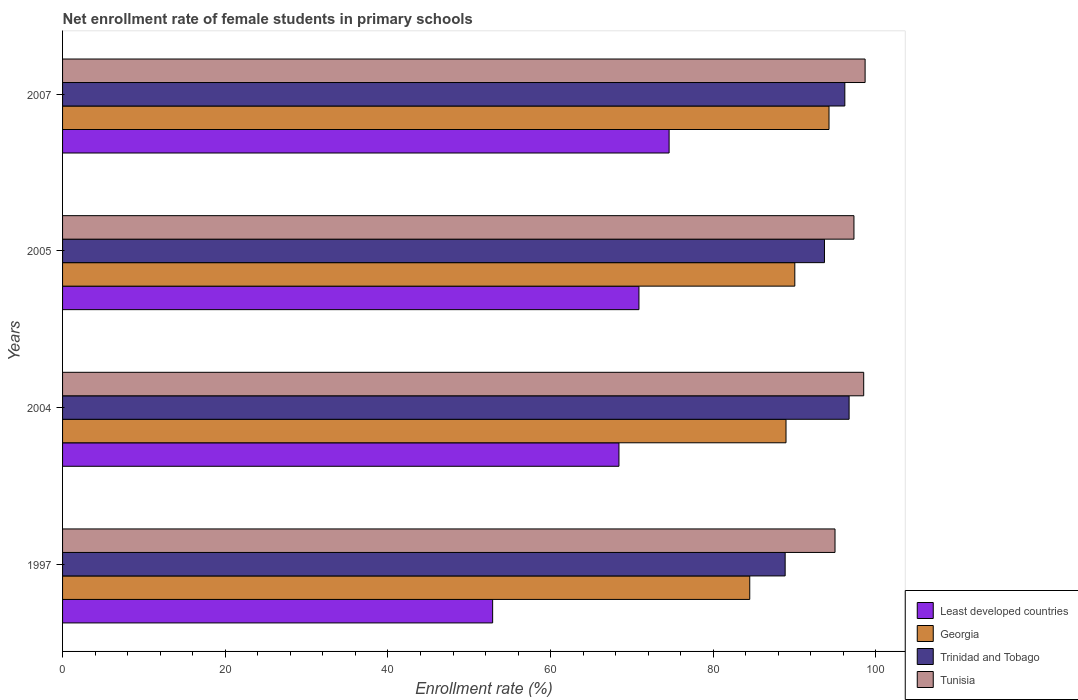How many different coloured bars are there?
Provide a succinct answer. 4. Are the number of bars per tick equal to the number of legend labels?
Your answer should be very brief. Yes. How many bars are there on the 1st tick from the top?
Your answer should be very brief. 4. What is the label of the 1st group of bars from the top?
Your response must be concise. 2007. In how many cases, is the number of bars for a given year not equal to the number of legend labels?
Your response must be concise. 0. What is the net enrollment rate of female students in primary schools in Tunisia in 1997?
Your response must be concise. 94.97. Across all years, what is the maximum net enrollment rate of female students in primary schools in Trinidad and Tobago?
Your response must be concise. 96.7. Across all years, what is the minimum net enrollment rate of female students in primary schools in Tunisia?
Give a very brief answer. 94.97. In which year was the net enrollment rate of female students in primary schools in Georgia minimum?
Offer a very short reply. 1997. What is the total net enrollment rate of female students in primary schools in Trinidad and Tobago in the graph?
Provide a short and direct response. 375.38. What is the difference between the net enrollment rate of female students in primary schools in Tunisia in 2004 and that in 2005?
Your response must be concise. 1.2. What is the difference between the net enrollment rate of female students in primary schools in Least developed countries in 2004 and the net enrollment rate of female students in primary schools in Tunisia in 2005?
Give a very brief answer. -28.89. What is the average net enrollment rate of female students in primary schools in Tunisia per year?
Your response must be concise. 97.36. In the year 1997, what is the difference between the net enrollment rate of female students in primary schools in Least developed countries and net enrollment rate of female students in primary schools in Trinidad and Tobago?
Provide a short and direct response. -35.96. In how many years, is the net enrollment rate of female students in primary schools in Georgia greater than 64 %?
Ensure brevity in your answer.  4. What is the ratio of the net enrollment rate of female students in primary schools in Georgia in 2005 to that in 2007?
Your answer should be compact. 0.96. Is the difference between the net enrollment rate of female students in primary schools in Least developed countries in 1997 and 2005 greater than the difference between the net enrollment rate of female students in primary schools in Trinidad and Tobago in 1997 and 2005?
Your response must be concise. No. What is the difference between the highest and the second highest net enrollment rate of female students in primary schools in Trinidad and Tobago?
Your response must be concise. 0.53. What is the difference between the highest and the lowest net enrollment rate of female students in primary schools in Georgia?
Keep it short and to the point. 9.75. Is the sum of the net enrollment rate of female students in primary schools in Tunisia in 2004 and 2005 greater than the maximum net enrollment rate of female students in primary schools in Trinidad and Tobago across all years?
Give a very brief answer. Yes. What does the 3rd bar from the top in 1997 represents?
Your response must be concise. Georgia. What does the 2nd bar from the bottom in 2004 represents?
Keep it short and to the point. Georgia. Is it the case that in every year, the sum of the net enrollment rate of female students in primary schools in Georgia and net enrollment rate of female students in primary schools in Trinidad and Tobago is greater than the net enrollment rate of female students in primary schools in Tunisia?
Your answer should be very brief. Yes. Are all the bars in the graph horizontal?
Offer a very short reply. Yes. How many years are there in the graph?
Keep it short and to the point. 4. Does the graph contain any zero values?
Your answer should be compact. No. Where does the legend appear in the graph?
Your answer should be compact. Bottom right. How many legend labels are there?
Offer a very short reply. 4. How are the legend labels stacked?
Provide a short and direct response. Vertical. What is the title of the graph?
Offer a very short reply. Net enrollment rate of female students in primary schools. Does "Netherlands" appear as one of the legend labels in the graph?
Make the answer very short. No. What is the label or title of the X-axis?
Offer a very short reply. Enrollment rate (%). What is the label or title of the Y-axis?
Keep it short and to the point. Years. What is the Enrollment rate (%) of Least developed countries in 1997?
Ensure brevity in your answer.  52.87. What is the Enrollment rate (%) in Georgia in 1997?
Make the answer very short. 84.48. What is the Enrollment rate (%) of Trinidad and Tobago in 1997?
Offer a terse response. 88.84. What is the Enrollment rate (%) in Tunisia in 1997?
Keep it short and to the point. 94.97. What is the Enrollment rate (%) of Least developed countries in 2004?
Provide a succinct answer. 68.4. What is the Enrollment rate (%) of Georgia in 2004?
Offer a very short reply. 88.94. What is the Enrollment rate (%) in Trinidad and Tobago in 2004?
Offer a terse response. 96.7. What is the Enrollment rate (%) in Tunisia in 2004?
Your response must be concise. 98.49. What is the Enrollment rate (%) in Least developed countries in 2005?
Ensure brevity in your answer.  70.86. What is the Enrollment rate (%) of Georgia in 2005?
Offer a terse response. 90.02. What is the Enrollment rate (%) of Trinidad and Tobago in 2005?
Your response must be concise. 93.67. What is the Enrollment rate (%) in Tunisia in 2005?
Provide a short and direct response. 97.3. What is the Enrollment rate (%) of Least developed countries in 2007?
Ensure brevity in your answer.  74.57. What is the Enrollment rate (%) in Georgia in 2007?
Offer a terse response. 94.23. What is the Enrollment rate (%) in Trinidad and Tobago in 2007?
Your answer should be very brief. 96.17. What is the Enrollment rate (%) of Tunisia in 2007?
Your answer should be very brief. 98.67. Across all years, what is the maximum Enrollment rate (%) of Least developed countries?
Ensure brevity in your answer.  74.57. Across all years, what is the maximum Enrollment rate (%) of Georgia?
Your answer should be compact. 94.23. Across all years, what is the maximum Enrollment rate (%) in Trinidad and Tobago?
Make the answer very short. 96.7. Across all years, what is the maximum Enrollment rate (%) of Tunisia?
Offer a terse response. 98.67. Across all years, what is the minimum Enrollment rate (%) of Least developed countries?
Offer a very short reply. 52.87. Across all years, what is the minimum Enrollment rate (%) of Georgia?
Your answer should be compact. 84.48. Across all years, what is the minimum Enrollment rate (%) in Trinidad and Tobago?
Offer a terse response. 88.84. Across all years, what is the minimum Enrollment rate (%) of Tunisia?
Your answer should be very brief. 94.97. What is the total Enrollment rate (%) of Least developed countries in the graph?
Your answer should be compact. 266.71. What is the total Enrollment rate (%) of Georgia in the graph?
Your answer should be very brief. 357.68. What is the total Enrollment rate (%) of Trinidad and Tobago in the graph?
Give a very brief answer. 375.38. What is the total Enrollment rate (%) of Tunisia in the graph?
Offer a terse response. 389.42. What is the difference between the Enrollment rate (%) in Least developed countries in 1997 and that in 2004?
Make the answer very short. -15.53. What is the difference between the Enrollment rate (%) of Georgia in 1997 and that in 2004?
Make the answer very short. -4.46. What is the difference between the Enrollment rate (%) in Trinidad and Tobago in 1997 and that in 2004?
Offer a terse response. -7.86. What is the difference between the Enrollment rate (%) of Tunisia in 1997 and that in 2004?
Provide a succinct answer. -3.53. What is the difference between the Enrollment rate (%) of Least developed countries in 1997 and that in 2005?
Your response must be concise. -17.99. What is the difference between the Enrollment rate (%) of Georgia in 1997 and that in 2005?
Ensure brevity in your answer.  -5.54. What is the difference between the Enrollment rate (%) in Trinidad and Tobago in 1997 and that in 2005?
Keep it short and to the point. -4.83. What is the difference between the Enrollment rate (%) in Tunisia in 1997 and that in 2005?
Provide a short and direct response. -2.33. What is the difference between the Enrollment rate (%) in Least developed countries in 1997 and that in 2007?
Your answer should be compact. -21.7. What is the difference between the Enrollment rate (%) in Georgia in 1997 and that in 2007?
Offer a very short reply. -9.75. What is the difference between the Enrollment rate (%) in Trinidad and Tobago in 1997 and that in 2007?
Provide a short and direct response. -7.34. What is the difference between the Enrollment rate (%) of Tunisia in 1997 and that in 2007?
Offer a terse response. -3.7. What is the difference between the Enrollment rate (%) in Least developed countries in 2004 and that in 2005?
Your answer should be compact. -2.46. What is the difference between the Enrollment rate (%) in Georgia in 2004 and that in 2005?
Provide a succinct answer. -1.08. What is the difference between the Enrollment rate (%) of Trinidad and Tobago in 2004 and that in 2005?
Your answer should be compact. 3.03. What is the difference between the Enrollment rate (%) in Tunisia in 2004 and that in 2005?
Offer a very short reply. 1.2. What is the difference between the Enrollment rate (%) in Least developed countries in 2004 and that in 2007?
Make the answer very short. -6.17. What is the difference between the Enrollment rate (%) in Georgia in 2004 and that in 2007?
Your response must be concise. -5.29. What is the difference between the Enrollment rate (%) of Trinidad and Tobago in 2004 and that in 2007?
Your response must be concise. 0.53. What is the difference between the Enrollment rate (%) in Tunisia in 2004 and that in 2007?
Your response must be concise. -0.17. What is the difference between the Enrollment rate (%) of Least developed countries in 2005 and that in 2007?
Offer a very short reply. -3.71. What is the difference between the Enrollment rate (%) in Georgia in 2005 and that in 2007?
Ensure brevity in your answer.  -4.2. What is the difference between the Enrollment rate (%) in Trinidad and Tobago in 2005 and that in 2007?
Provide a short and direct response. -2.5. What is the difference between the Enrollment rate (%) of Tunisia in 2005 and that in 2007?
Your answer should be very brief. -1.37. What is the difference between the Enrollment rate (%) of Least developed countries in 1997 and the Enrollment rate (%) of Georgia in 2004?
Your answer should be very brief. -36.07. What is the difference between the Enrollment rate (%) of Least developed countries in 1997 and the Enrollment rate (%) of Trinidad and Tobago in 2004?
Provide a succinct answer. -43.82. What is the difference between the Enrollment rate (%) of Least developed countries in 1997 and the Enrollment rate (%) of Tunisia in 2004?
Provide a short and direct response. -45.62. What is the difference between the Enrollment rate (%) in Georgia in 1997 and the Enrollment rate (%) in Trinidad and Tobago in 2004?
Give a very brief answer. -12.22. What is the difference between the Enrollment rate (%) in Georgia in 1997 and the Enrollment rate (%) in Tunisia in 2004?
Provide a succinct answer. -14.01. What is the difference between the Enrollment rate (%) of Trinidad and Tobago in 1997 and the Enrollment rate (%) of Tunisia in 2004?
Make the answer very short. -9.66. What is the difference between the Enrollment rate (%) of Least developed countries in 1997 and the Enrollment rate (%) of Georgia in 2005?
Provide a succinct answer. -37.15. What is the difference between the Enrollment rate (%) of Least developed countries in 1997 and the Enrollment rate (%) of Trinidad and Tobago in 2005?
Provide a short and direct response. -40.8. What is the difference between the Enrollment rate (%) in Least developed countries in 1997 and the Enrollment rate (%) in Tunisia in 2005?
Keep it short and to the point. -44.42. What is the difference between the Enrollment rate (%) of Georgia in 1997 and the Enrollment rate (%) of Trinidad and Tobago in 2005?
Give a very brief answer. -9.19. What is the difference between the Enrollment rate (%) in Georgia in 1997 and the Enrollment rate (%) in Tunisia in 2005?
Your answer should be very brief. -12.81. What is the difference between the Enrollment rate (%) of Trinidad and Tobago in 1997 and the Enrollment rate (%) of Tunisia in 2005?
Your answer should be compact. -8.46. What is the difference between the Enrollment rate (%) of Least developed countries in 1997 and the Enrollment rate (%) of Georgia in 2007?
Your response must be concise. -41.35. What is the difference between the Enrollment rate (%) of Least developed countries in 1997 and the Enrollment rate (%) of Trinidad and Tobago in 2007?
Keep it short and to the point. -43.3. What is the difference between the Enrollment rate (%) in Least developed countries in 1997 and the Enrollment rate (%) in Tunisia in 2007?
Offer a terse response. -45.79. What is the difference between the Enrollment rate (%) in Georgia in 1997 and the Enrollment rate (%) in Trinidad and Tobago in 2007?
Give a very brief answer. -11.69. What is the difference between the Enrollment rate (%) in Georgia in 1997 and the Enrollment rate (%) in Tunisia in 2007?
Your answer should be compact. -14.18. What is the difference between the Enrollment rate (%) in Trinidad and Tobago in 1997 and the Enrollment rate (%) in Tunisia in 2007?
Your answer should be compact. -9.83. What is the difference between the Enrollment rate (%) of Least developed countries in 2004 and the Enrollment rate (%) of Georgia in 2005?
Keep it short and to the point. -21.62. What is the difference between the Enrollment rate (%) of Least developed countries in 2004 and the Enrollment rate (%) of Trinidad and Tobago in 2005?
Make the answer very short. -25.27. What is the difference between the Enrollment rate (%) of Least developed countries in 2004 and the Enrollment rate (%) of Tunisia in 2005?
Provide a short and direct response. -28.89. What is the difference between the Enrollment rate (%) in Georgia in 2004 and the Enrollment rate (%) in Trinidad and Tobago in 2005?
Your answer should be compact. -4.73. What is the difference between the Enrollment rate (%) of Georgia in 2004 and the Enrollment rate (%) of Tunisia in 2005?
Give a very brief answer. -8.35. What is the difference between the Enrollment rate (%) of Trinidad and Tobago in 2004 and the Enrollment rate (%) of Tunisia in 2005?
Your response must be concise. -0.6. What is the difference between the Enrollment rate (%) of Least developed countries in 2004 and the Enrollment rate (%) of Georgia in 2007?
Your answer should be compact. -25.83. What is the difference between the Enrollment rate (%) of Least developed countries in 2004 and the Enrollment rate (%) of Trinidad and Tobago in 2007?
Your answer should be very brief. -27.77. What is the difference between the Enrollment rate (%) of Least developed countries in 2004 and the Enrollment rate (%) of Tunisia in 2007?
Give a very brief answer. -30.26. What is the difference between the Enrollment rate (%) in Georgia in 2004 and the Enrollment rate (%) in Trinidad and Tobago in 2007?
Your answer should be compact. -7.23. What is the difference between the Enrollment rate (%) of Georgia in 2004 and the Enrollment rate (%) of Tunisia in 2007?
Offer a terse response. -9.72. What is the difference between the Enrollment rate (%) in Trinidad and Tobago in 2004 and the Enrollment rate (%) in Tunisia in 2007?
Your response must be concise. -1.97. What is the difference between the Enrollment rate (%) of Least developed countries in 2005 and the Enrollment rate (%) of Georgia in 2007?
Give a very brief answer. -23.37. What is the difference between the Enrollment rate (%) of Least developed countries in 2005 and the Enrollment rate (%) of Trinidad and Tobago in 2007?
Give a very brief answer. -25.31. What is the difference between the Enrollment rate (%) in Least developed countries in 2005 and the Enrollment rate (%) in Tunisia in 2007?
Give a very brief answer. -27.81. What is the difference between the Enrollment rate (%) in Georgia in 2005 and the Enrollment rate (%) in Trinidad and Tobago in 2007?
Give a very brief answer. -6.15. What is the difference between the Enrollment rate (%) in Georgia in 2005 and the Enrollment rate (%) in Tunisia in 2007?
Keep it short and to the point. -8.64. What is the difference between the Enrollment rate (%) of Trinidad and Tobago in 2005 and the Enrollment rate (%) of Tunisia in 2007?
Offer a very short reply. -5. What is the average Enrollment rate (%) in Least developed countries per year?
Provide a succinct answer. 66.68. What is the average Enrollment rate (%) in Georgia per year?
Make the answer very short. 89.42. What is the average Enrollment rate (%) in Trinidad and Tobago per year?
Provide a succinct answer. 93.84. What is the average Enrollment rate (%) in Tunisia per year?
Ensure brevity in your answer.  97.36. In the year 1997, what is the difference between the Enrollment rate (%) of Least developed countries and Enrollment rate (%) of Georgia?
Give a very brief answer. -31.61. In the year 1997, what is the difference between the Enrollment rate (%) of Least developed countries and Enrollment rate (%) of Trinidad and Tobago?
Your response must be concise. -35.96. In the year 1997, what is the difference between the Enrollment rate (%) of Least developed countries and Enrollment rate (%) of Tunisia?
Your answer should be compact. -42.09. In the year 1997, what is the difference between the Enrollment rate (%) in Georgia and Enrollment rate (%) in Trinidad and Tobago?
Provide a succinct answer. -4.35. In the year 1997, what is the difference between the Enrollment rate (%) of Georgia and Enrollment rate (%) of Tunisia?
Offer a very short reply. -10.48. In the year 1997, what is the difference between the Enrollment rate (%) of Trinidad and Tobago and Enrollment rate (%) of Tunisia?
Your answer should be compact. -6.13. In the year 2004, what is the difference between the Enrollment rate (%) in Least developed countries and Enrollment rate (%) in Georgia?
Ensure brevity in your answer.  -20.54. In the year 2004, what is the difference between the Enrollment rate (%) of Least developed countries and Enrollment rate (%) of Trinidad and Tobago?
Your answer should be very brief. -28.3. In the year 2004, what is the difference between the Enrollment rate (%) in Least developed countries and Enrollment rate (%) in Tunisia?
Give a very brief answer. -30.09. In the year 2004, what is the difference between the Enrollment rate (%) in Georgia and Enrollment rate (%) in Trinidad and Tobago?
Ensure brevity in your answer.  -7.76. In the year 2004, what is the difference between the Enrollment rate (%) of Georgia and Enrollment rate (%) of Tunisia?
Your answer should be very brief. -9.55. In the year 2004, what is the difference between the Enrollment rate (%) of Trinidad and Tobago and Enrollment rate (%) of Tunisia?
Offer a terse response. -1.79. In the year 2005, what is the difference between the Enrollment rate (%) of Least developed countries and Enrollment rate (%) of Georgia?
Give a very brief answer. -19.16. In the year 2005, what is the difference between the Enrollment rate (%) in Least developed countries and Enrollment rate (%) in Trinidad and Tobago?
Your answer should be compact. -22.81. In the year 2005, what is the difference between the Enrollment rate (%) of Least developed countries and Enrollment rate (%) of Tunisia?
Your answer should be compact. -26.43. In the year 2005, what is the difference between the Enrollment rate (%) of Georgia and Enrollment rate (%) of Trinidad and Tobago?
Give a very brief answer. -3.65. In the year 2005, what is the difference between the Enrollment rate (%) in Georgia and Enrollment rate (%) in Tunisia?
Make the answer very short. -7.27. In the year 2005, what is the difference between the Enrollment rate (%) of Trinidad and Tobago and Enrollment rate (%) of Tunisia?
Make the answer very short. -3.63. In the year 2007, what is the difference between the Enrollment rate (%) in Least developed countries and Enrollment rate (%) in Georgia?
Your answer should be compact. -19.66. In the year 2007, what is the difference between the Enrollment rate (%) of Least developed countries and Enrollment rate (%) of Trinidad and Tobago?
Ensure brevity in your answer.  -21.6. In the year 2007, what is the difference between the Enrollment rate (%) in Least developed countries and Enrollment rate (%) in Tunisia?
Provide a short and direct response. -24.1. In the year 2007, what is the difference between the Enrollment rate (%) of Georgia and Enrollment rate (%) of Trinidad and Tobago?
Your answer should be compact. -1.94. In the year 2007, what is the difference between the Enrollment rate (%) of Georgia and Enrollment rate (%) of Tunisia?
Keep it short and to the point. -4.44. In the year 2007, what is the difference between the Enrollment rate (%) in Trinidad and Tobago and Enrollment rate (%) in Tunisia?
Give a very brief answer. -2.49. What is the ratio of the Enrollment rate (%) of Least developed countries in 1997 to that in 2004?
Offer a terse response. 0.77. What is the ratio of the Enrollment rate (%) in Georgia in 1997 to that in 2004?
Offer a very short reply. 0.95. What is the ratio of the Enrollment rate (%) of Trinidad and Tobago in 1997 to that in 2004?
Keep it short and to the point. 0.92. What is the ratio of the Enrollment rate (%) of Tunisia in 1997 to that in 2004?
Provide a succinct answer. 0.96. What is the ratio of the Enrollment rate (%) of Least developed countries in 1997 to that in 2005?
Your response must be concise. 0.75. What is the ratio of the Enrollment rate (%) of Georgia in 1997 to that in 2005?
Your response must be concise. 0.94. What is the ratio of the Enrollment rate (%) in Trinidad and Tobago in 1997 to that in 2005?
Ensure brevity in your answer.  0.95. What is the ratio of the Enrollment rate (%) in Tunisia in 1997 to that in 2005?
Offer a very short reply. 0.98. What is the ratio of the Enrollment rate (%) of Least developed countries in 1997 to that in 2007?
Keep it short and to the point. 0.71. What is the ratio of the Enrollment rate (%) in Georgia in 1997 to that in 2007?
Your answer should be compact. 0.9. What is the ratio of the Enrollment rate (%) in Trinidad and Tobago in 1997 to that in 2007?
Your answer should be very brief. 0.92. What is the ratio of the Enrollment rate (%) in Tunisia in 1997 to that in 2007?
Offer a terse response. 0.96. What is the ratio of the Enrollment rate (%) in Least developed countries in 2004 to that in 2005?
Ensure brevity in your answer.  0.97. What is the ratio of the Enrollment rate (%) of Trinidad and Tobago in 2004 to that in 2005?
Provide a succinct answer. 1.03. What is the ratio of the Enrollment rate (%) in Tunisia in 2004 to that in 2005?
Provide a succinct answer. 1.01. What is the ratio of the Enrollment rate (%) in Least developed countries in 2004 to that in 2007?
Your response must be concise. 0.92. What is the ratio of the Enrollment rate (%) of Georgia in 2004 to that in 2007?
Give a very brief answer. 0.94. What is the ratio of the Enrollment rate (%) in Tunisia in 2004 to that in 2007?
Keep it short and to the point. 1. What is the ratio of the Enrollment rate (%) of Least developed countries in 2005 to that in 2007?
Offer a terse response. 0.95. What is the ratio of the Enrollment rate (%) of Georgia in 2005 to that in 2007?
Make the answer very short. 0.96. What is the ratio of the Enrollment rate (%) in Tunisia in 2005 to that in 2007?
Your answer should be very brief. 0.99. What is the difference between the highest and the second highest Enrollment rate (%) of Least developed countries?
Your answer should be very brief. 3.71. What is the difference between the highest and the second highest Enrollment rate (%) of Georgia?
Give a very brief answer. 4.2. What is the difference between the highest and the second highest Enrollment rate (%) of Trinidad and Tobago?
Provide a succinct answer. 0.53. What is the difference between the highest and the second highest Enrollment rate (%) of Tunisia?
Your response must be concise. 0.17. What is the difference between the highest and the lowest Enrollment rate (%) in Least developed countries?
Ensure brevity in your answer.  21.7. What is the difference between the highest and the lowest Enrollment rate (%) of Georgia?
Offer a terse response. 9.75. What is the difference between the highest and the lowest Enrollment rate (%) of Trinidad and Tobago?
Keep it short and to the point. 7.86. What is the difference between the highest and the lowest Enrollment rate (%) in Tunisia?
Your answer should be very brief. 3.7. 